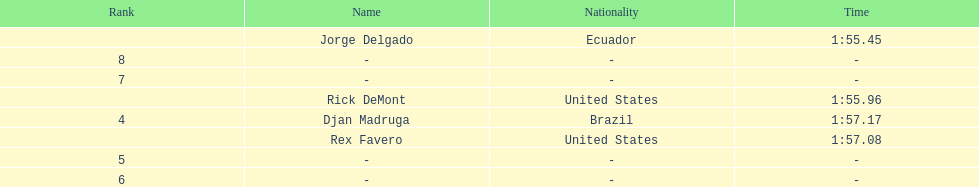Favero finished in 1:57.08. what was the next time? 1:57.17. 